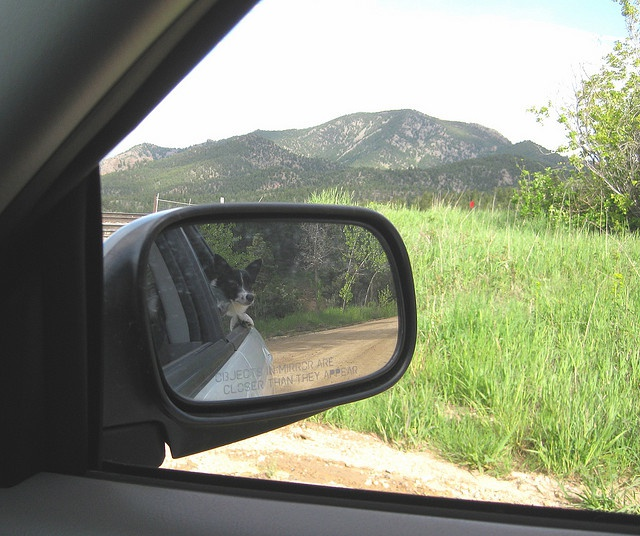Describe the objects in this image and their specific colors. I can see car in gray, purple, darkgray, and black tones and dog in gray, black, and purple tones in this image. 